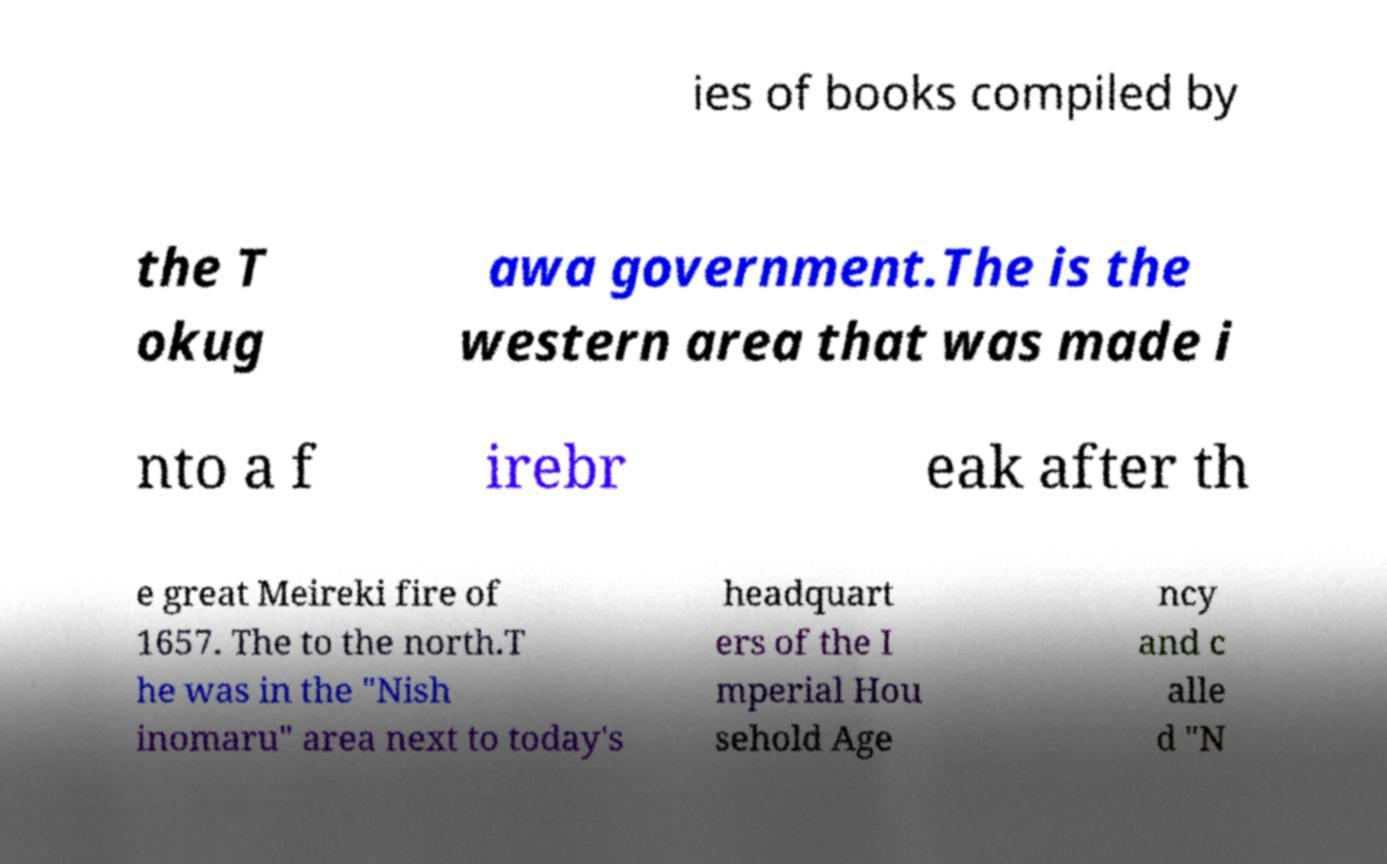There's text embedded in this image that I need extracted. Can you transcribe it verbatim? ies of books compiled by the T okug awa government.The is the western area that was made i nto a f irebr eak after th e great Meireki fire of 1657. The to the north.T he was in the "Nish inomaru" area next to today's headquart ers of the I mperial Hou sehold Age ncy and c alle d "N 